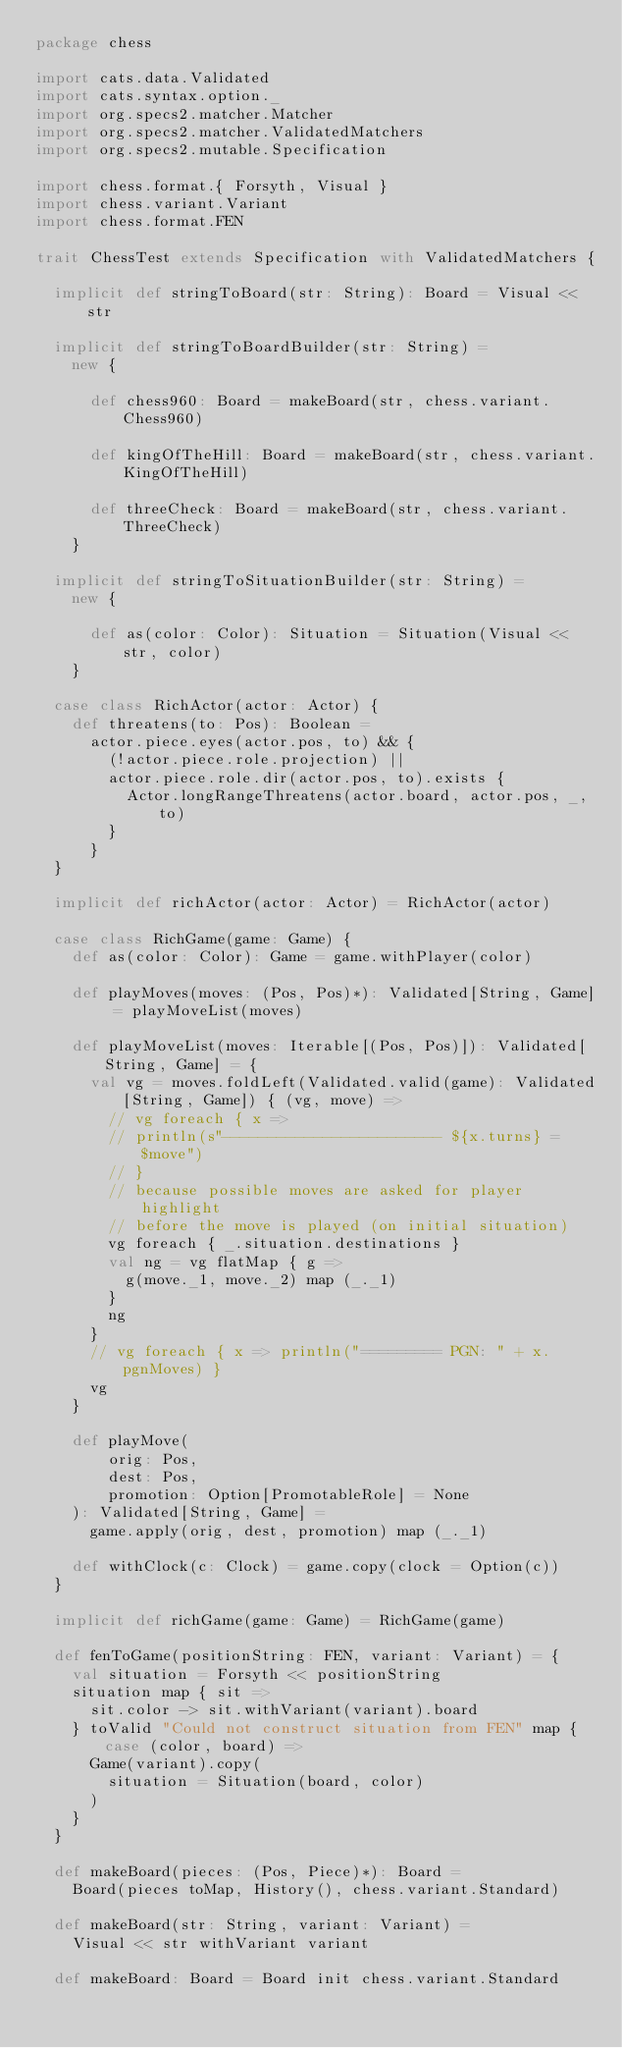Convert code to text. <code><loc_0><loc_0><loc_500><loc_500><_Scala_>package chess

import cats.data.Validated
import cats.syntax.option._
import org.specs2.matcher.Matcher
import org.specs2.matcher.ValidatedMatchers
import org.specs2.mutable.Specification

import chess.format.{ Forsyth, Visual }
import chess.variant.Variant
import chess.format.FEN

trait ChessTest extends Specification with ValidatedMatchers {

  implicit def stringToBoard(str: String): Board = Visual << str

  implicit def stringToBoardBuilder(str: String) =
    new {

      def chess960: Board = makeBoard(str, chess.variant.Chess960)

      def kingOfTheHill: Board = makeBoard(str, chess.variant.KingOfTheHill)

      def threeCheck: Board = makeBoard(str, chess.variant.ThreeCheck)
    }

  implicit def stringToSituationBuilder(str: String) =
    new {

      def as(color: Color): Situation = Situation(Visual << str, color)
    }

  case class RichActor(actor: Actor) {
    def threatens(to: Pos): Boolean =
      actor.piece.eyes(actor.pos, to) && {
        (!actor.piece.role.projection) ||
        actor.piece.role.dir(actor.pos, to).exists {
          Actor.longRangeThreatens(actor.board, actor.pos, _, to)
        }
      }
  }

  implicit def richActor(actor: Actor) = RichActor(actor)

  case class RichGame(game: Game) {
    def as(color: Color): Game = game.withPlayer(color)

    def playMoves(moves: (Pos, Pos)*): Validated[String, Game] = playMoveList(moves)

    def playMoveList(moves: Iterable[(Pos, Pos)]): Validated[String, Game] = {
      val vg = moves.foldLeft(Validated.valid(game): Validated[String, Game]) { (vg, move) =>
        // vg foreach { x =>
        // println(s"------------------------ ${x.turns} = $move")
        // }
        // because possible moves are asked for player highlight
        // before the move is played (on initial situation)
        vg foreach { _.situation.destinations }
        val ng = vg flatMap { g =>
          g(move._1, move._2) map (_._1)
        }
        ng
      }
      // vg foreach { x => println("========= PGN: " + x.pgnMoves) }
      vg
    }

    def playMove(
        orig: Pos,
        dest: Pos,
        promotion: Option[PromotableRole] = None
    ): Validated[String, Game] =
      game.apply(orig, dest, promotion) map (_._1)

    def withClock(c: Clock) = game.copy(clock = Option(c))
  }

  implicit def richGame(game: Game) = RichGame(game)

  def fenToGame(positionString: FEN, variant: Variant) = {
    val situation = Forsyth << positionString
    situation map { sit =>
      sit.color -> sit.withVariant(variant).board
    } toValid "Could not construct situation from FEN" map { case (color, board) =>
      Game(variant).copy(
        situation = Situation(board, color)
      )
    }
  }

  def makeBoard(pieces: (Pos, Piece)*): Board =
    Board(pieces toMap, History(), chess.variant.Standard)

  def makeBoard(str: String, variant: Variant) =
    Visual << str withVariant variant

  def makeBoard: Board = Board init chess.variant.Standard
</code> 